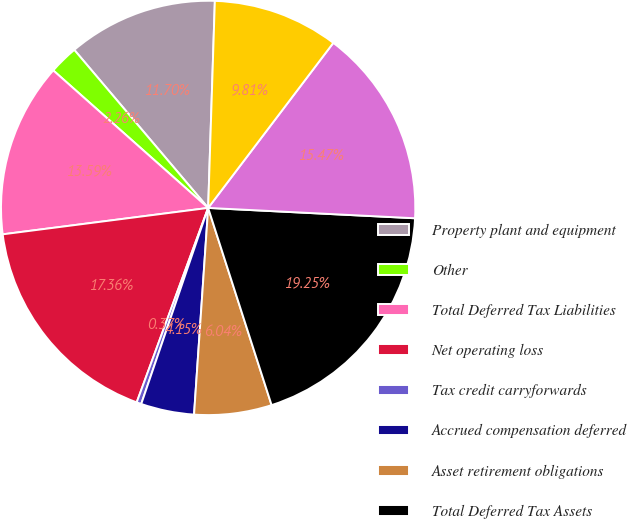<chart> <loc_0><loc_0><loc_500><loc_500><pie_chart><fcel>Property plant and equipment<fcel>Other<fcel>Total Deferred Tax Liabilities<fcel>Net operating loss<fcel>Tax credit carryforwards<fcel>Accrued compensation deferred<fcel>Asset retirement obligations<fcel>Total Deferred Tax Assets<fcel>Valuation allowances<fcel>Total deferred tax assets net<nl><fcel>11.7%<fcel>2.26%<fcel>13.59%<fcel>17.36%<fcel>0.37%<fcel>4.15%<fcel>6.04%<fcel>19.25%<fcel>15.47%<fcel>9.81%<nl></chart> 